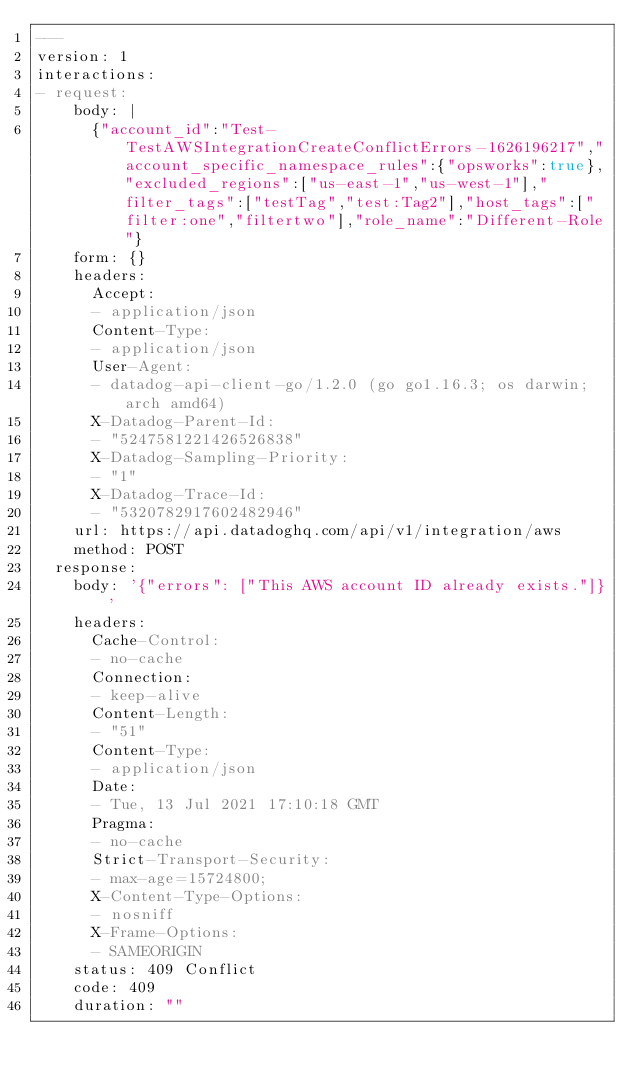Convert code to text. <code><loc_0><loc_0><loc_500><loc_500><_YAML_>---
version: 1
interactions:
- request:
    body: |
      {"account_id":"Test-TestAWSIntegrationCreateConflictErrors-1626196217","account_specific_namespace_rules":{"opsworks":true},"excluded_regions":["us-east-1","us-west-1"],"filter_tags":["testTag","test:Tag2"],"host_tags":["filter:one","filtertwo"],"role_name":"Different-Role"}
    form: {}
    headers:
      Accept:
      - application/json
      Content-Type:
      - application/json
      User-Agent:
      - datadog-api-client-go/1.2.0 (go go1.16.3; os darwin; arch amd64)
      X-Datadog-Parent-Id:
      - "5247581221426526838"
      X-Datadog-Sampling-Priority:
      - "1"
      X-Datadog-Trace-Id:
      - "5320782917602482946"
    url: https://api.datadoghq.com/api/v1/integration/aws
    method: POST
  response:
    body: '{"errors": ["This AWS account ID already exists."]}'
    headers:
      Cache-Control:
      - no-cache
      Connection:
      - keep-alive
      Content-Length:
      - "51"
      Content-Type:
      - application/json
      Date:
      - Tue, 13 Jul 2021 17:10:18 GMT
      Pragma:
      - no-cache
      Strict-Transport-Security:
      - max-age=15724800;
      X-Content-Type-Options:
      - nosniff
      X-Frame-Options:
      - SAMEORIGIN
    status: 409 Conflict
    code: 409
    duration: ""
</code> 